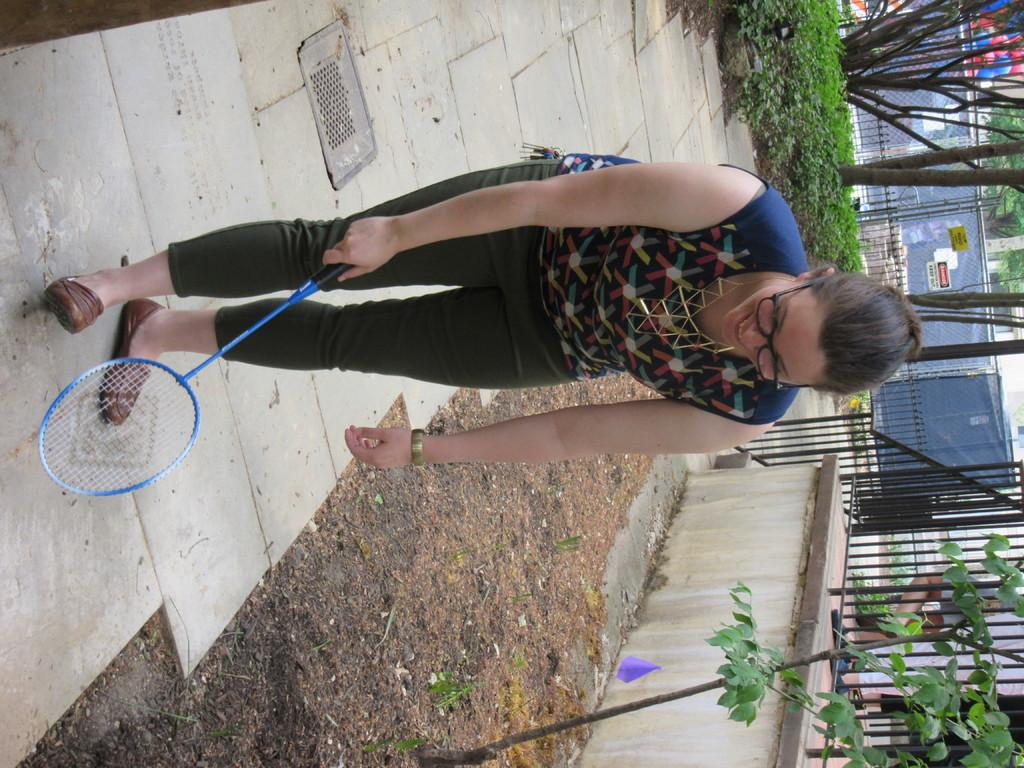Who is present in the image? There is a woman in the image. What is the woman holding in the image? The woman is holding a badminton racket. What can be seen in the background of the image? There are trees and buildings in the background of the image. What type of bead is the woman using to play badminton in the image? There is no bead present in the image; the woman is holding a badminton racket. How many parcels can be seen in the image? There are no parcels present in the image. 